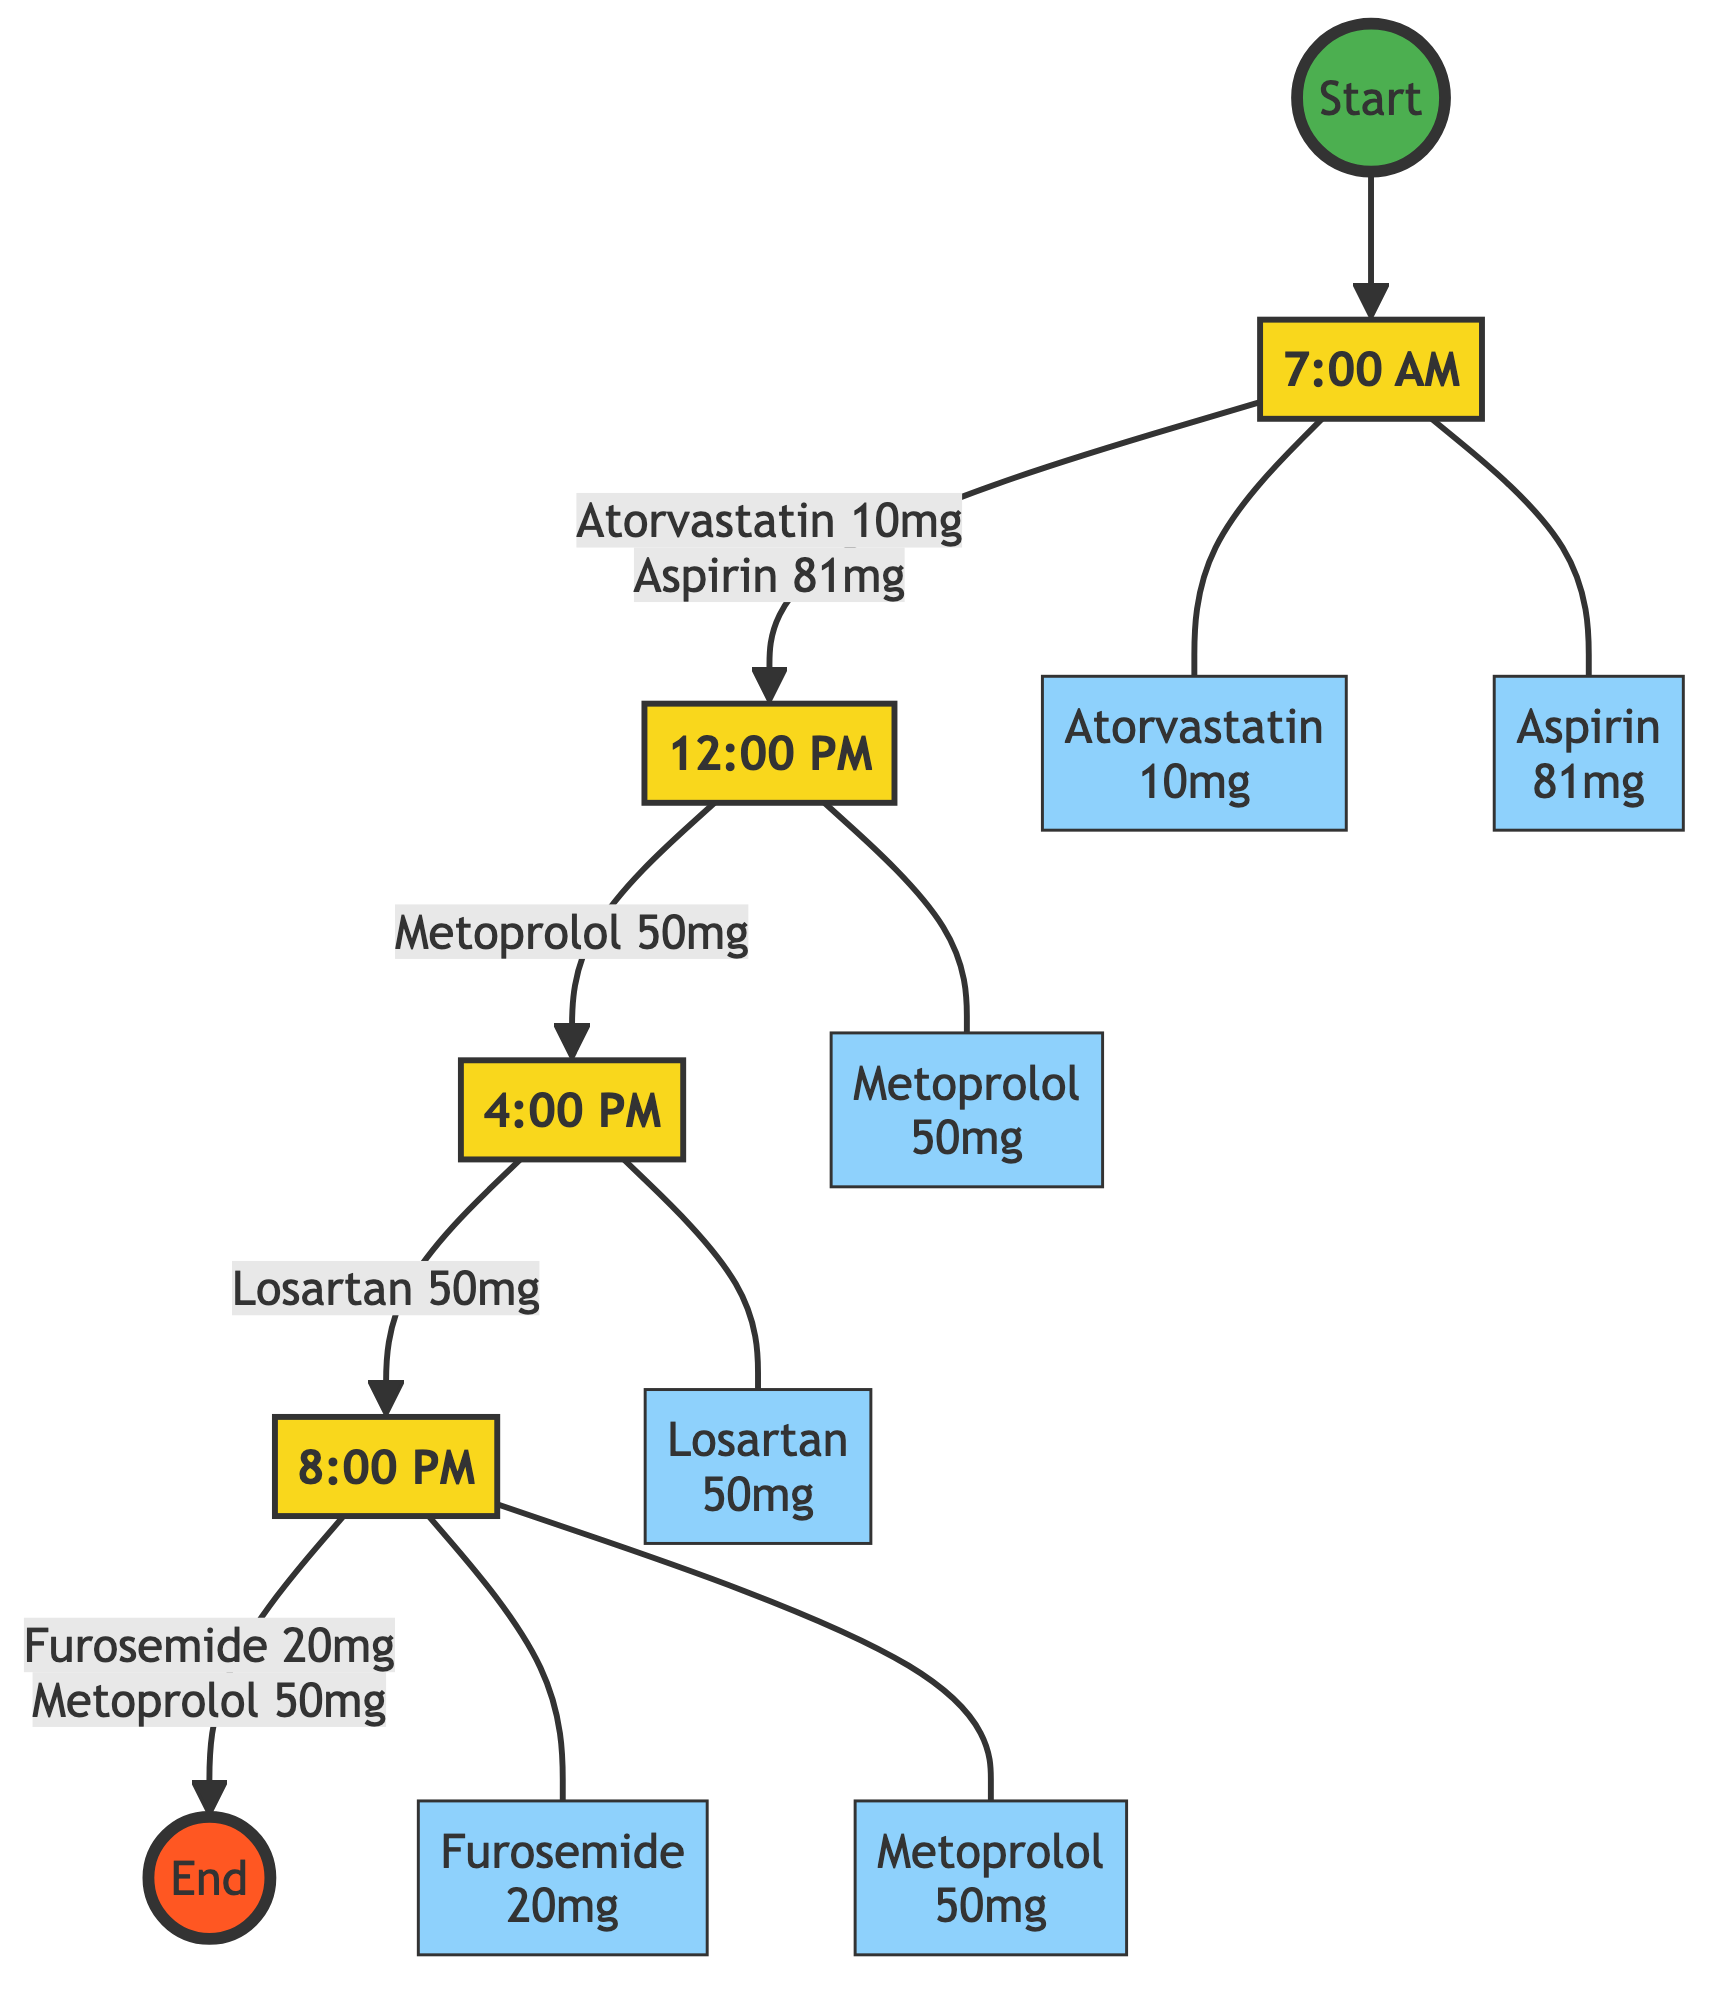What medications are taken in the morning? The diagram shows that the medications taken in the morning (7:00 AM) are Atorvastatin 10 mg and Aspirin 81 mg.
Answer: Atorvastatin 10 mg, Aspirin 81 mg How many times is Metoprolol taken daily? According to the diagram, Metoprolol is indicated to be taken twice daily, as shown at both Midday and Evening.
Answer: Twice daily What is the dosage of Furosemide? The diagram indicates that Furosemide is taken at an Evening dose of 20 mg.
Answer: 20 mg Which medication is taken after Losartan? Observing the flow from Afternoon to Evening in the diagram, it shows that Furosemide is taken after Losartan.
Answer: Furosemide How many steps are there in the pathway? Counting the distinct time steps from Start to End, we have Morning, Midday, Afternoon, and Evening, totaling 4 steps.
Answer: 4 steps What is the instruction for taking Atorvastatin? The diagram specifically states that Atorvastatin should be taken once daily in the morning.
Answer: Taken once daily What is the sequence of medications taken from Midday to Evening? The diagram shows the transition from Midday to Afternoon as Metoprolol, and then from Afternoon to Evening as Losartan followed by Furosemide and Metoprolol again.
Answer: Metoprolol, Losartan, Furosemide, Metoprolol What is the time for taking Losartan? The diagram indicates that Losartan is taken in the Afternoon at 4:00 PM.
Answer: 4:00 PM 